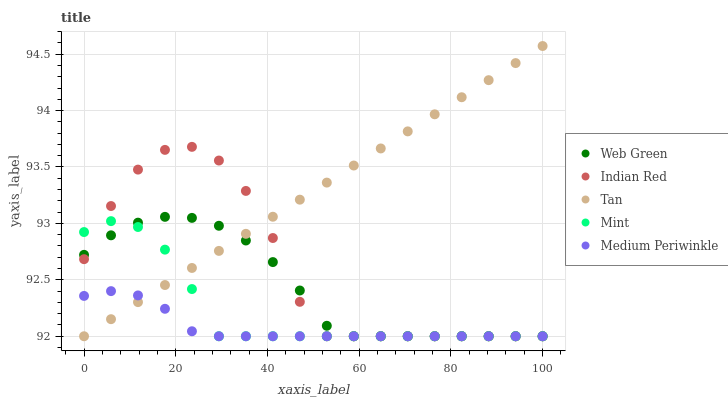Does Medium Periwinkle have the minimum area under the curve?
Answer yes or no. Yes. Does Tan have the maximum area under the curve?
Answer yes or no. Yes. Does Mint have the minimum area under the curve?
Answer yes or no. No. Does Mint have the maximum area under the curve?
Answer yes or no. No. Is Tan the smoothest?
Answer yes or no. Yes. Is Indian Red the roughest?
Answer yes or no. Yes. Is Mint the smoothest?
Answer yes or no. No. Is Mint the roughest?
Answer yes or no. No. Does Medium Periwinkle have the lowest value?
Answer yes or no. Yes. Does Tan have the highest value?
Answer yes or no. Yes. Does Mint have the highest value?
Answer yes or no. No. Does Medium Periwinkle intersect Tan?
Answer yes or no. Yes. Is Medium Periwinkle less than Tan?
Answer yes or no. No. Is Medium Periwinkle greater than Tan?
Answer yes or no. No. 